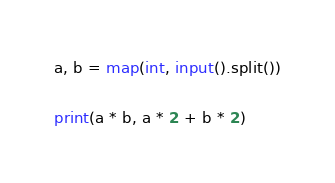Convert code to text. <code><loc_0><loc_0><loc_500><loc_500><_Python_>a, b = map(int, input().split())

print(a * b, a * 2 + b * 2)</code> 